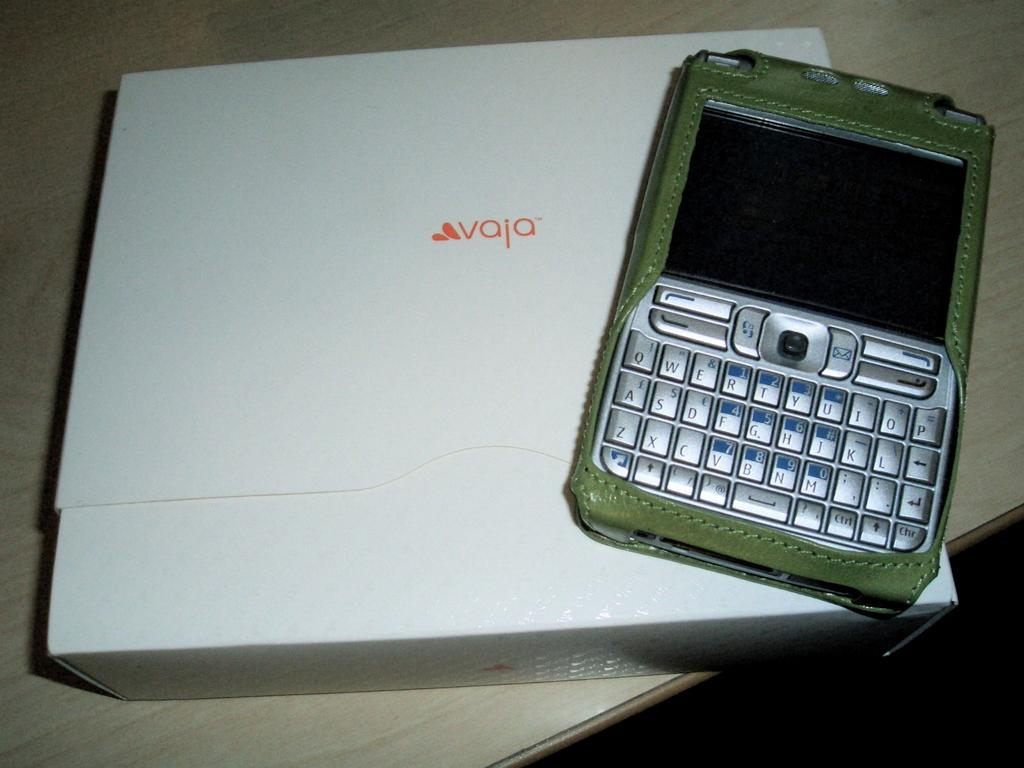<image>
Write a terse but informative summary of the picture. A phone sits on a box with the word vaja written in orange. 